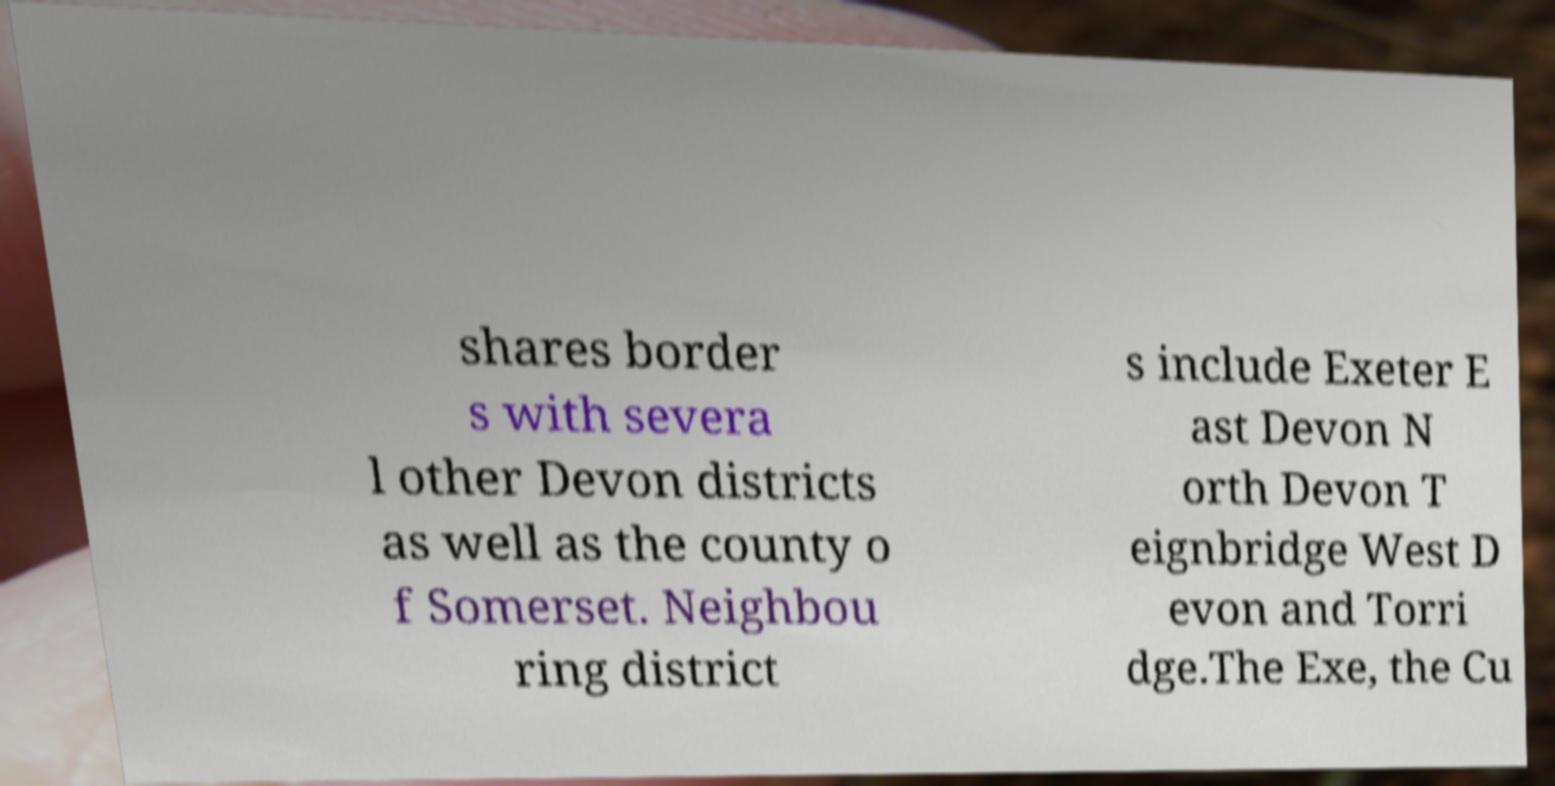Can you accurately transcribe the text from the provided image for me? shares border s with severa l other Devon districts as well as the county o f Somerset. Neighbou ring district s include Exeter E ast Devon N orth Devon T eignbridge West D evon and Torri dge.The Exe, the Cu 